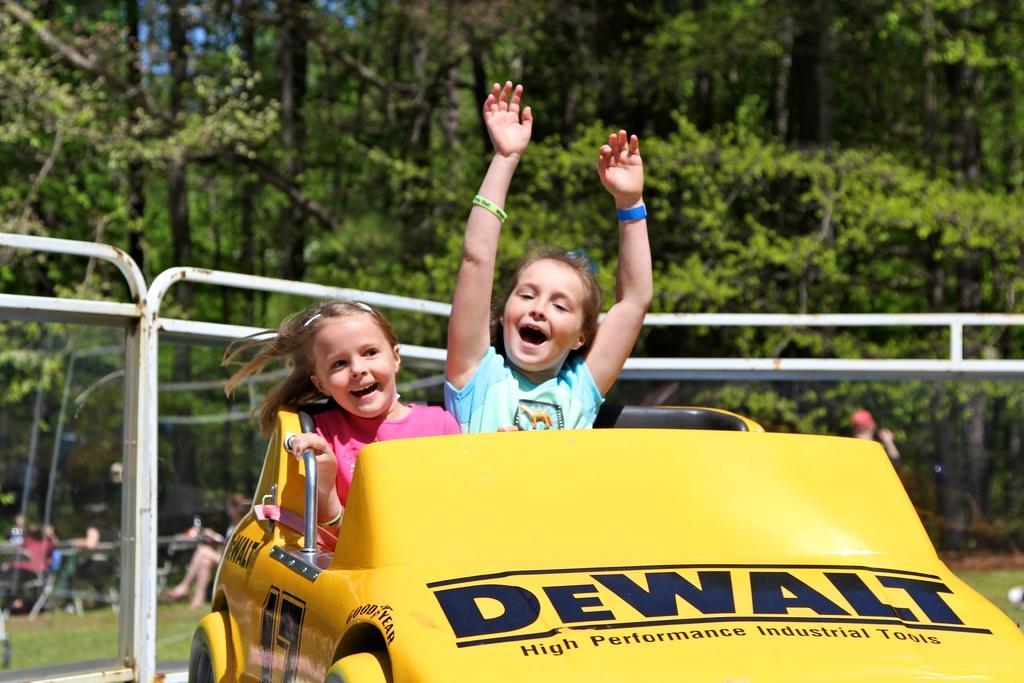Please provide a concise description of this image. In this picture we can see a yellow color car in the front, there are two kids sitting in the car, in the background there are some trees, we can see some people sitting at the left bottom, there is some text on the car. 